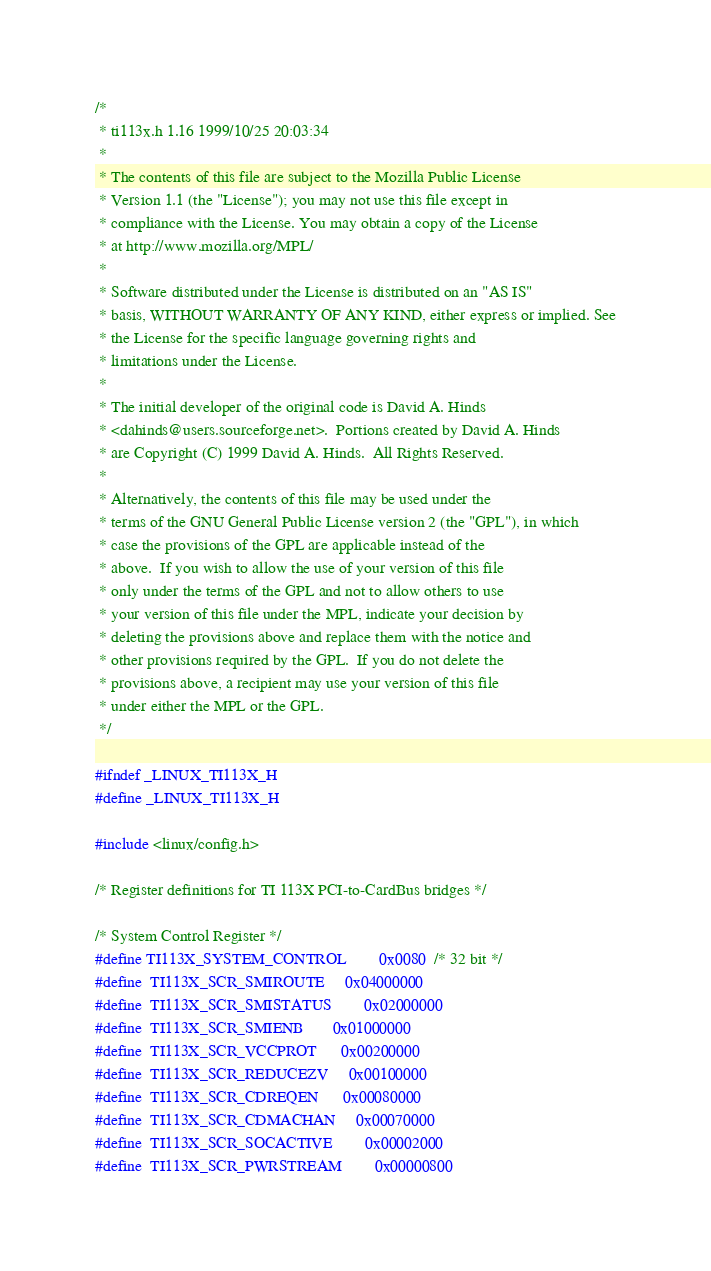<code> <loc_0><loc_0><loc_500><loc_500><_C_>/*
 * ti113x.h 1.16 1999/10/25 20:03:34
 *
 * The contents of this file are subject to the Mozilla Public License
 * Version 1.1 (the "License"); you may not use this file except in
 * compliance with the License. You may obtain a copy of the License
 * at http://www.mozilla.org/MPL/
 *
 * Software distributed under the License is distributed on an "AS IS"
 * basis, WITHOUT WARRANTY OF ANY KIND, either express or implied. See
 * the License for the specific language governing rights and
 * limitations under the License. 
 *
 * The initial developer of the original code is David A. Hinds
 * <dahinds@users.sourceforge.net>.  Portions created by David A. Hinds
 * are Copyright (C) 1999 David A. Hinds.  All Rights Reserved.
 *
 * Alternatively, the contents of this file may be used under the
 * terms of the GNU General Public License version 2 (the "GPL"), in which
 * case the provisions of the GPL are applicable instead of the
 * above.  If you wish to allow the use of your version of this file
 * only under the terms of the GPL and not to allow others to use
 * your version of this file under the MPL, indicate your decision by
 * deleting the provisions above and replace them with the notice and
 * other provisions required by the GPL.  If you do not delete the
 * provisions above, a recipient may use your version of this file
 * under either the MPL or the GPL.
 */

#ifndef _LINUX_TI113X_H
#define _LINUX_TI113X_H

#include <linux/config.h>

/* Register definitions for TI 113X PCI-to-CardBus bridges */

/* System Control Register */
#define TI113X_SYSTEM_CONTROL		0x0080	/* 32 bit */
#define  TI113X_SCR_SMIROUTE		0x04000000
#define  TI113X_SCR_SMISTATUS		0x02000000
#define  TI113X_SCR_SMIENB		0x01000000
#define  TI113X_SCR_VCCPROT		0x00200000
#define  TI113X_SCR_REDUCEZV		0x00100000
#define  TI113X_SCR_CDREQEN		0x00080000
#define  TI113X_SCR_CDMACHAN		0x00070000
#define  TI113X_SCR_SOCACTIVE		0x00002000
#define  TI113X_SCR_PWRSTREAM		0x00000800</code> 